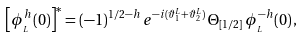<formula> <loc_0><loc_0><loc_500><loc_500>\left [ \phi _ { _ { L } } ^ { h } ( { 0 } ) \right ] ^ { * } = ( - 1 ) ^ { 1 / 2 - h } \, e ^ { - i ( \vartheta _ { 1 } ^ { L } + \vartheta _ { 2 } ^ { L } ) } \, \Theta _ { [ 1 / 2 ] } \, \phi _ { _ { L } } ^ { - h } ( { 0 } ) \, ,</formula> 